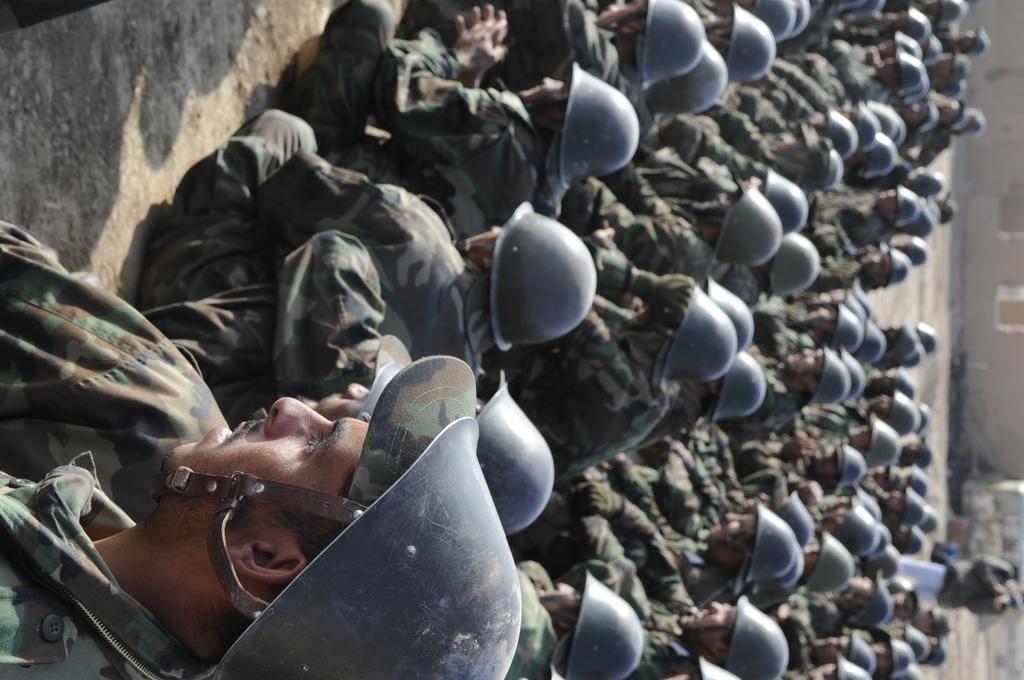In one or two sentences, can you explain what this image depicts? In this image we can see there is a group of people sitting on the ground. And one person standing and holding a camera. At the back it looks like a building. 